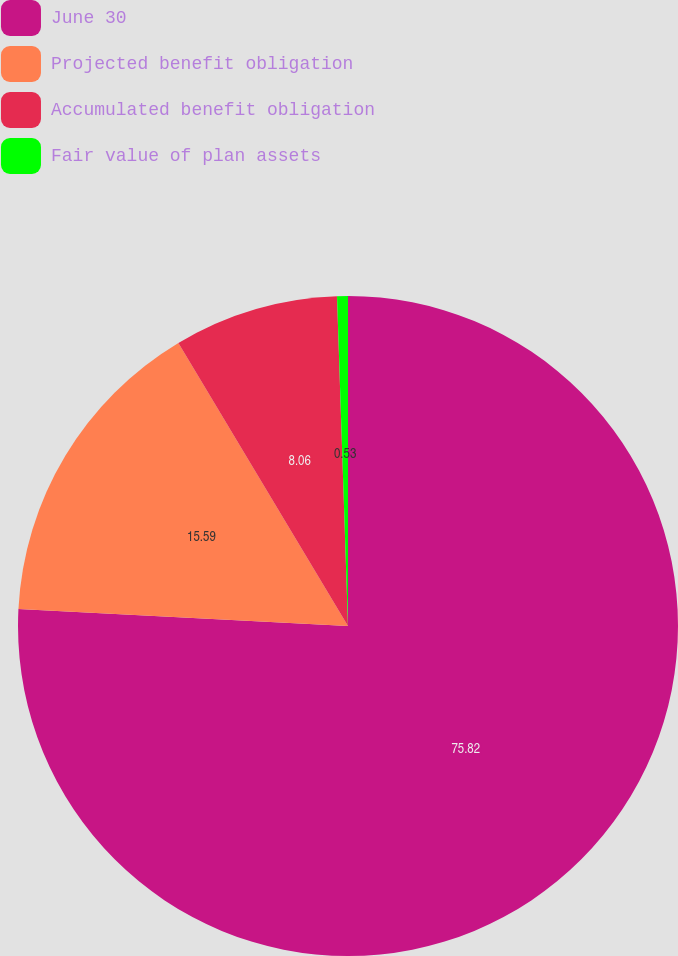<chart> <loc_0><loc_0><loc_500><loc_500><pie_chart><fcel>June 30<fcel>Projected benefit obligation<fcel>Accumulated benefit obligation<fcel>Fair value of plan assets<nl><fcel>75.81%<fcel>15.59%<fcel>8.06%<fcel>0.53%<nl></chart> 